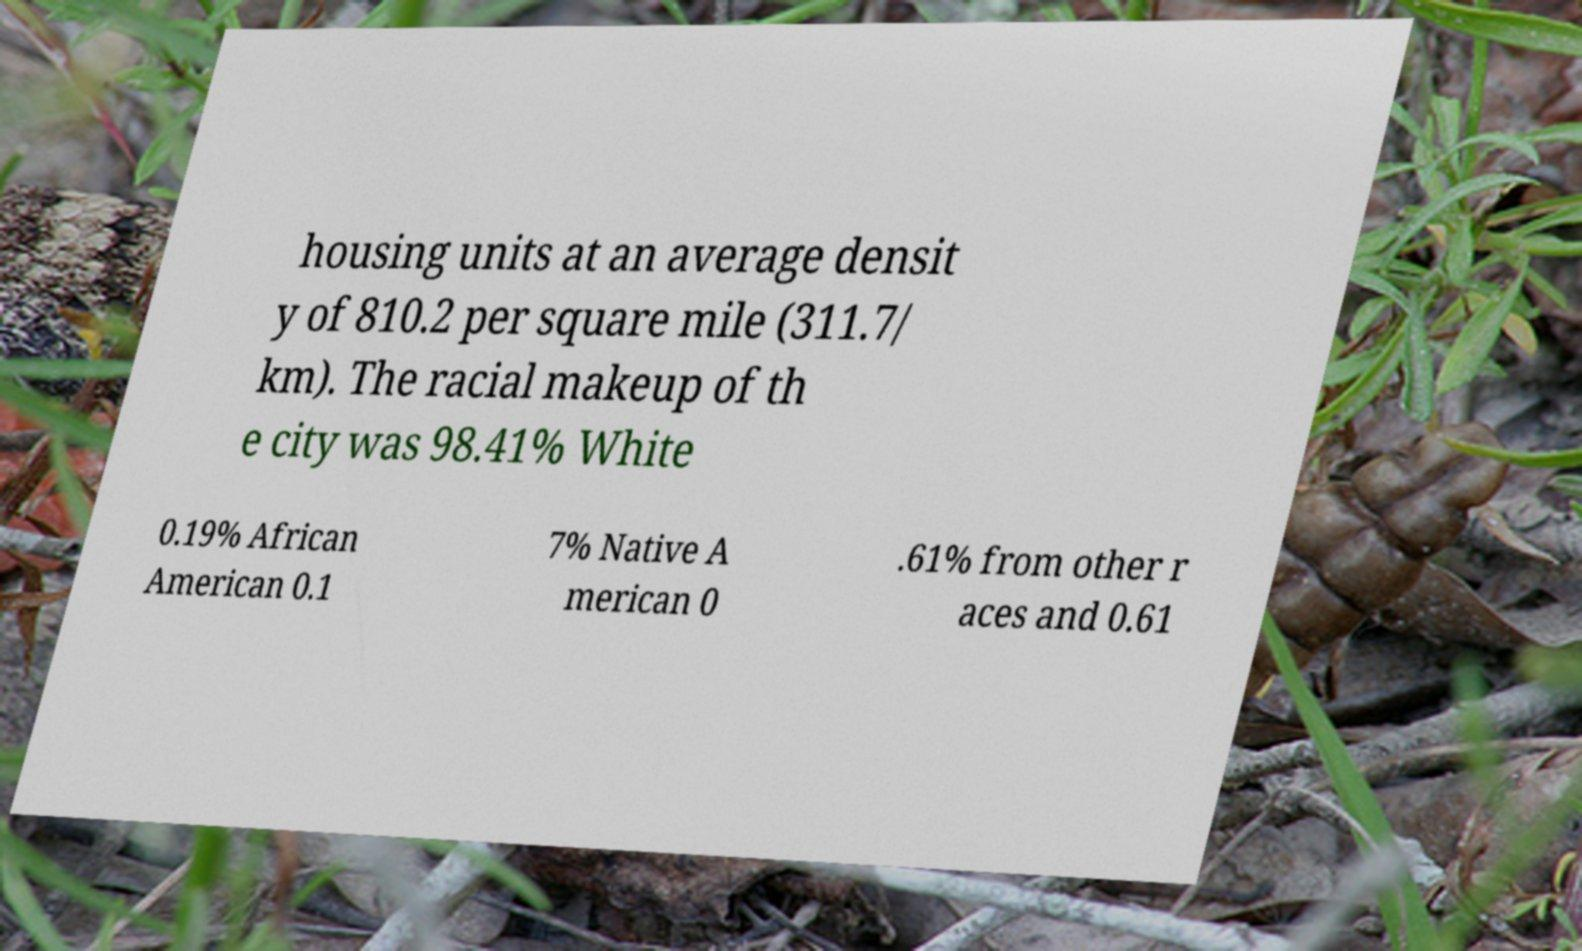Could you assist in decoding the text presented in this image and type it out clearly? housing units at an average densit y of 810.2 per square mile (311.7/ km). The racial makeup of th e city was 98.41% White 0.19% African American 0.1 7% Native A merican 0 .61% from other r aces and 0.61 